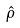Convert formula to latex. <formula><loc_0><loc_0><loc_500><loc_500>\hat { \rho }</formula> 